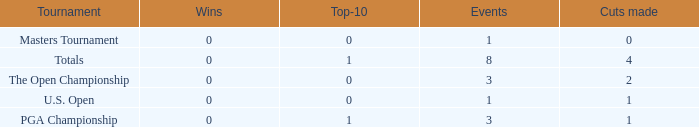For events with values of exactly 1, and 0 cuts made, what is the fewest number of top-10s? 0.0. 